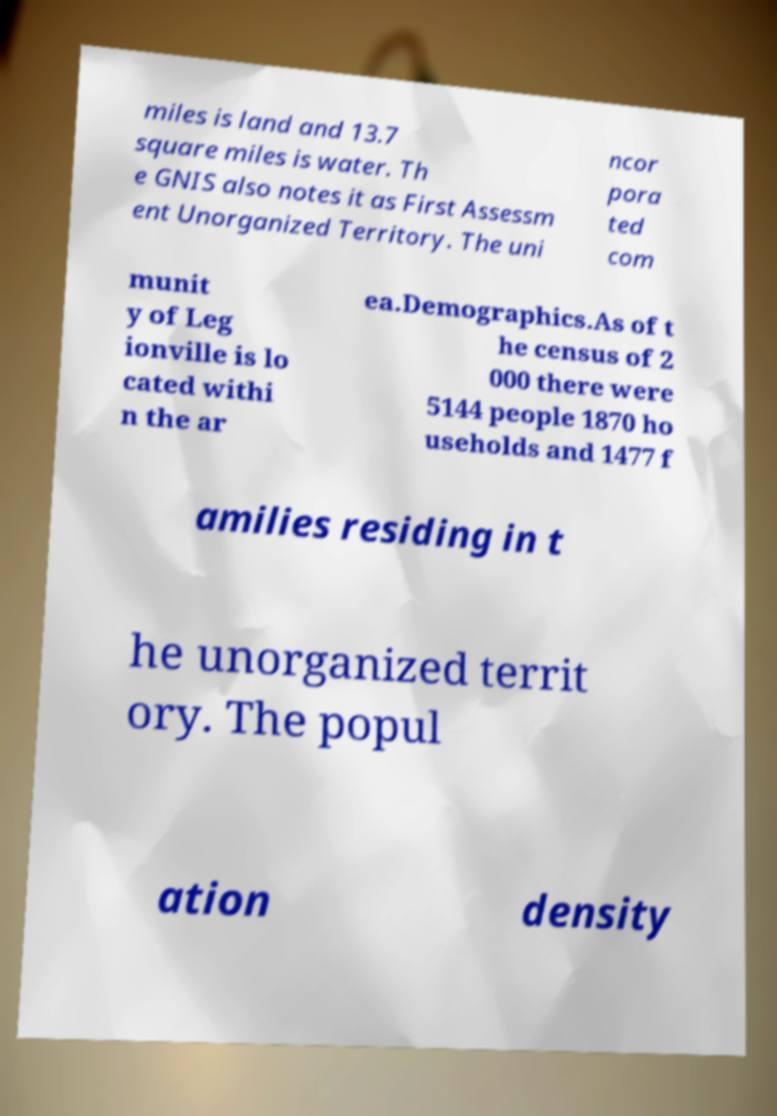Can you accurately transcribe the text from the provided image for me? miles is land and 13.7 square miles is water. Th e GNIS also notes it as First Assessm ent Unorganized Territory. The uni ncor pora ted com munit y of Leg ionville is lo cated withi n the ar ea.Demographics.As of t he census of 2 000 there were 5144 people 1870 ho useholds and 1477 f amilies residing in t he unorganized territ ory. The popul ation density 